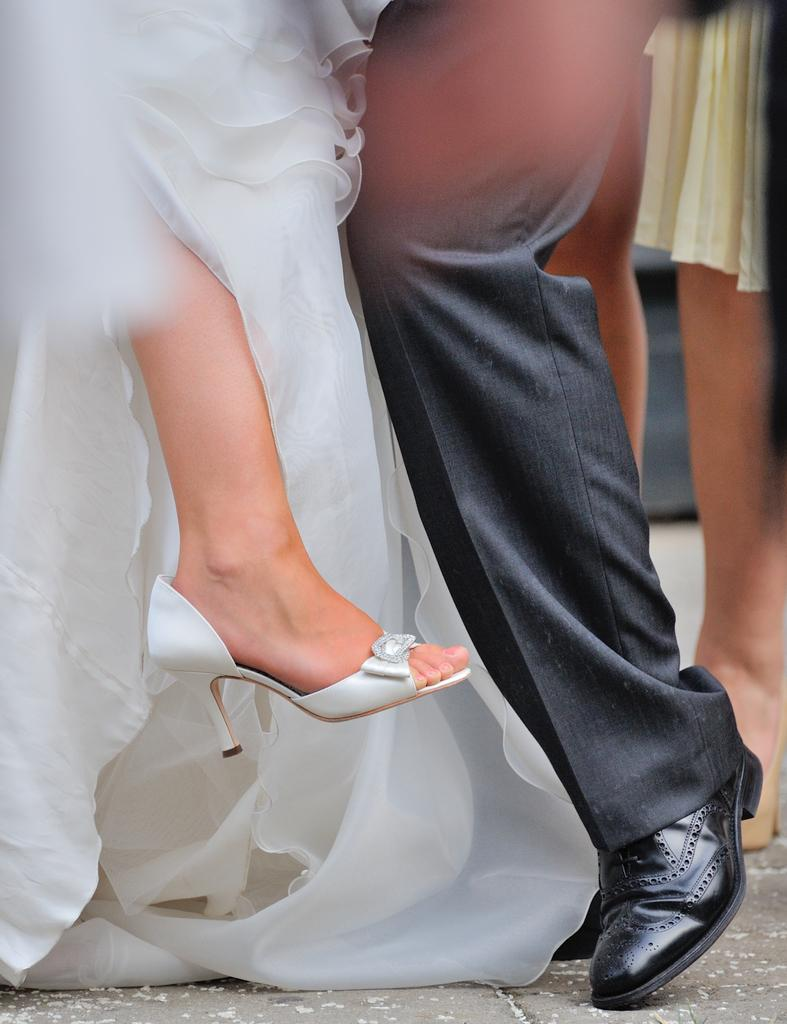What body part is visible in the image? There are legs visible in the image. Where are the legs located? The legs are on the ground. What type of clothing is associated with the legs in the image? There are dresses in the image. What type of footwear is visible in the image? There are shoes and sandals in the image. What type of flag is being waved by the legs in the image? There is no flag present in the image; it only features legs, dresses, shoes, and sandals. 